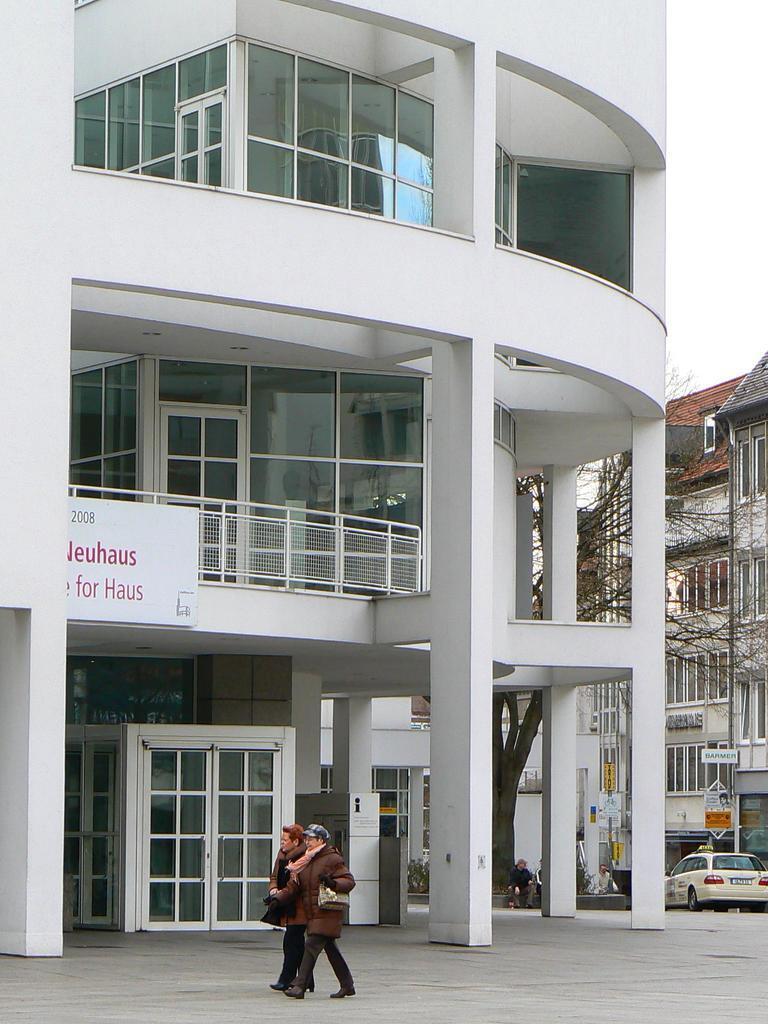Could you give a brief overview of what you see in this image? In this image, I can see two people walking on the pathway. There are buildings with name boards and a tree. On the right side of the image, I can see a person sitting and a car. 